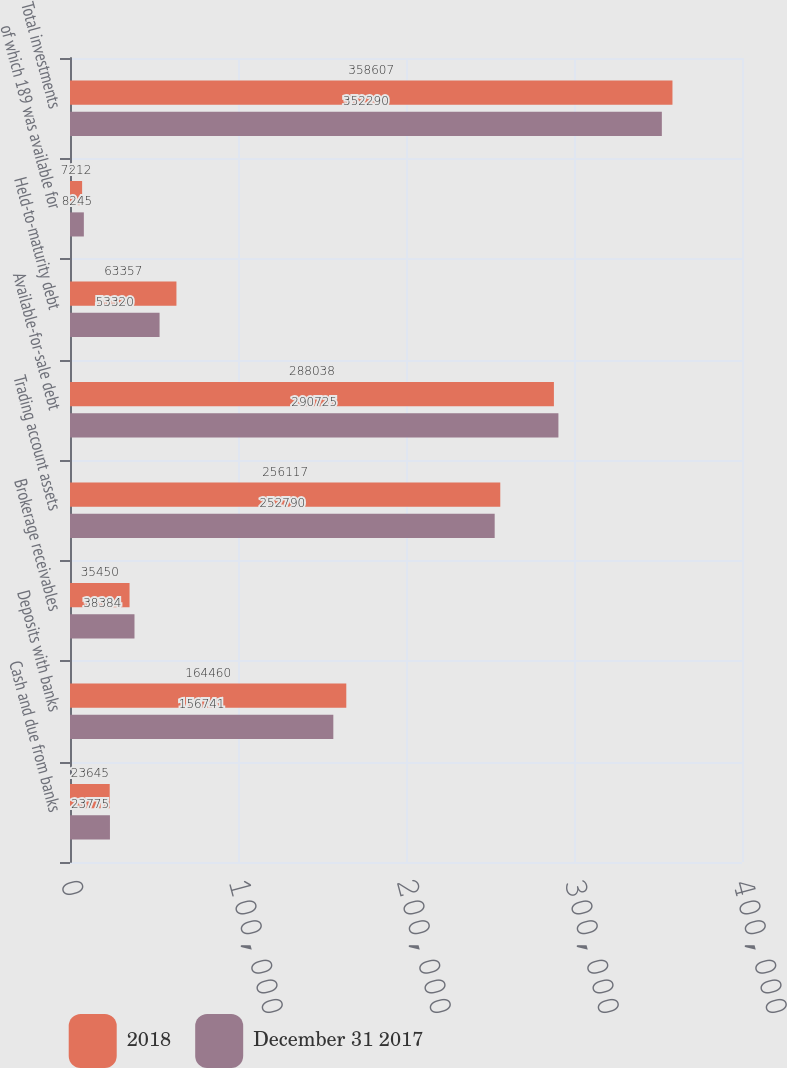Convert chart. <chart><loc_0><loc_0><loc_500><loc_500><stacked_bar_chart><ecel><fcel>Cash and due from banks<fcel>Deposits with banks<fcel>Brokerage receivables<fcel>Trading account assets<fcel>Available-for-sale debt<fcel>Held-to-maturity debt<fcel>of which 189 was available for<fcel>Total investments<nl><fcel>2018<fcel>23645<fcel>164460<fcel>35450<fcel>256117<fcel>288038<fcel>63357<fcel>7212<fcel>358607<nl><fcel>December 31 2017<fcel>23775<fcel>156741<fcel>38384<fcel>252790<fcel>290725<fcel>53320<fcel>8245<fcel>352290<nl></chart> 